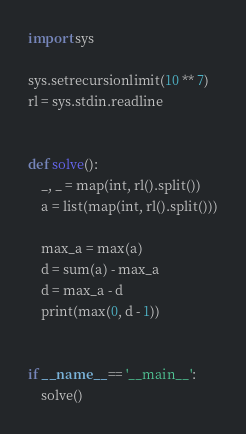<code> <loc_0><loc_0><loc_500><loc_500><_Python_>import sys

sys.setrecursionlimit(10 ** 7)
rl = sys.stdin.readline


def solve():
    _, _ = map(int, rl().split())
    a = list(map(int, rl().split()))
    
    max_a = max(a)
    d = sum(a) - max_a
    d = max_a - d
    print(max(0, d - 1))


if __name__ == '__main__':
    solve()
</code> 